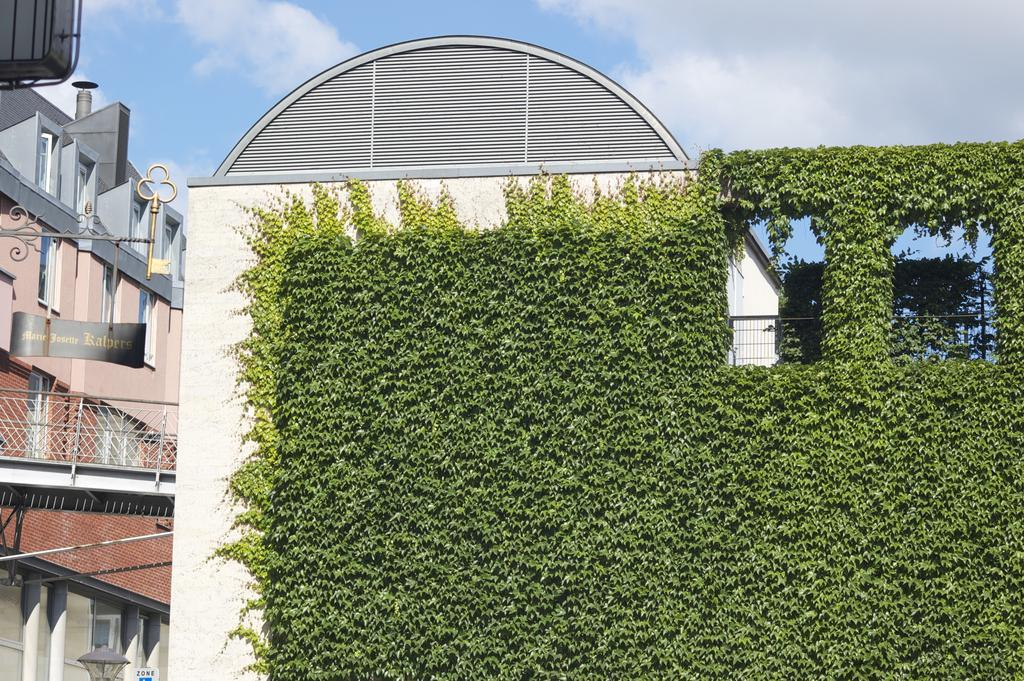What type of structures can be seen in the image? There are buildings in the image. What else is present in the image besides the buildings? There are plants and a boat with text in the image. Can you describe the boat in the image? The boat has text on it, but the specific text is not legible. Where is the light located in the image? The light is at the bottom left corner of the image. How would you describe the sky in the image? The sky is blue and cloudy in the image. How many pies are being sold at the market in the image? There is no market or pies present in the image. What type of notebook is the person using to take notes in the image? There is no person or notebook present in the image. 